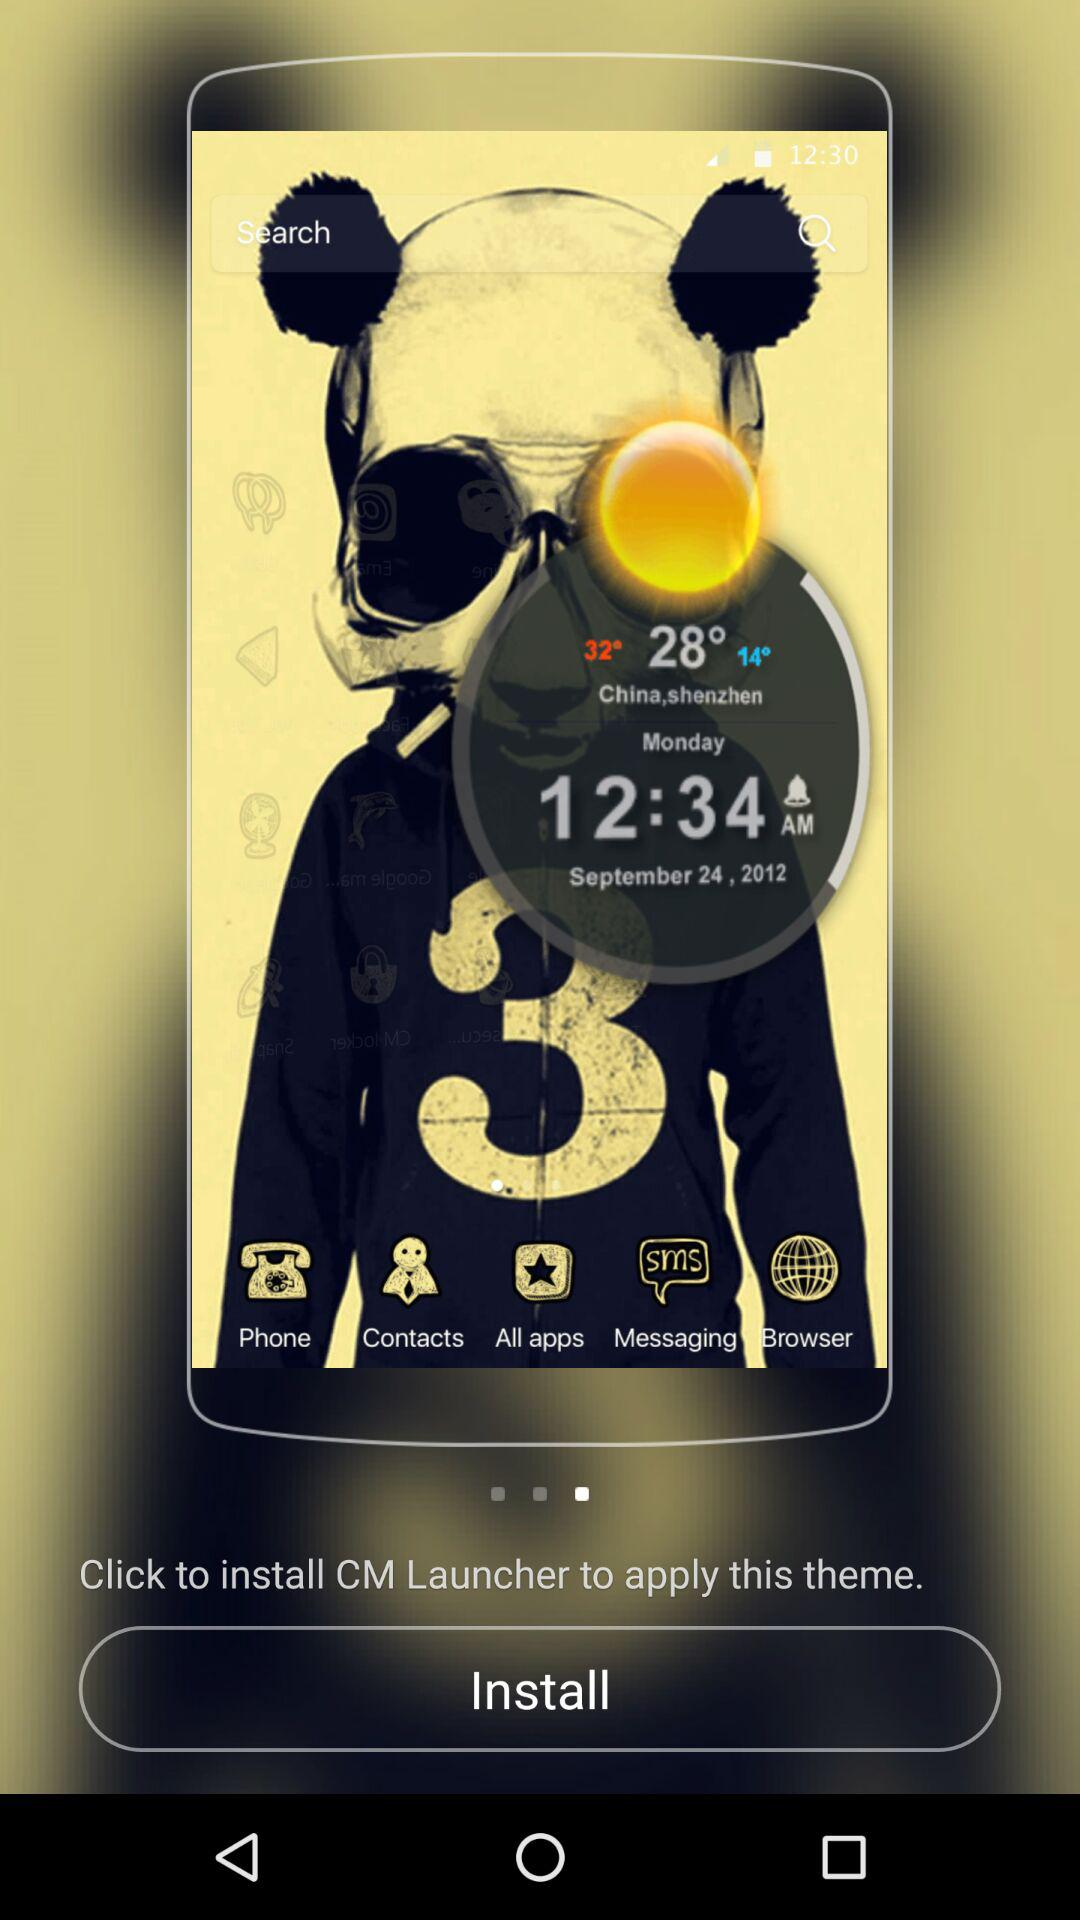What is the date on the theme? The date on the theme is September 24, 2012. 